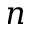Convert formula to latex. <formula><loc_0><loc_0><loc_500><loc_500>n</formula> 